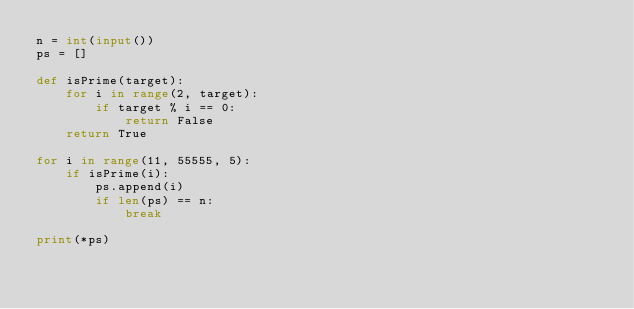Convert code to text. <code><loc_0><loc_0><loc_500><loc_500><_Python_>n = int(input())
ps = []

def isPrime(target):
    for i in range(2, target):
        if target % i == 0:
            return False
    return True

for i in range(11, 55555, 5):
    if isPrime(i):
        ps.append(i)
        if len(ps) == n:
            break

print(*ps)</code> 